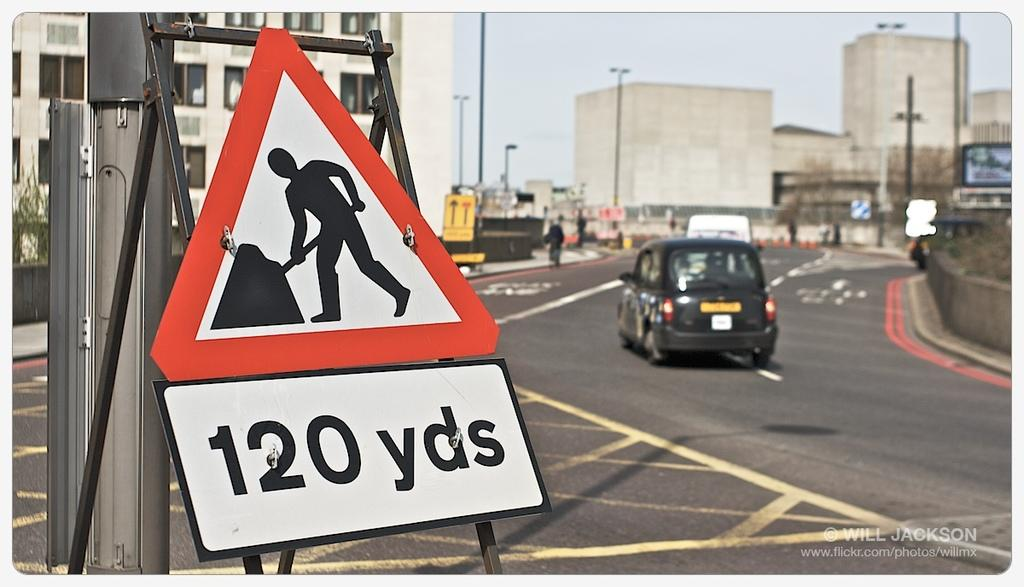<image>
Describe the image concisely. A triangular sign along a street warns of construction workers in 120 yards. 